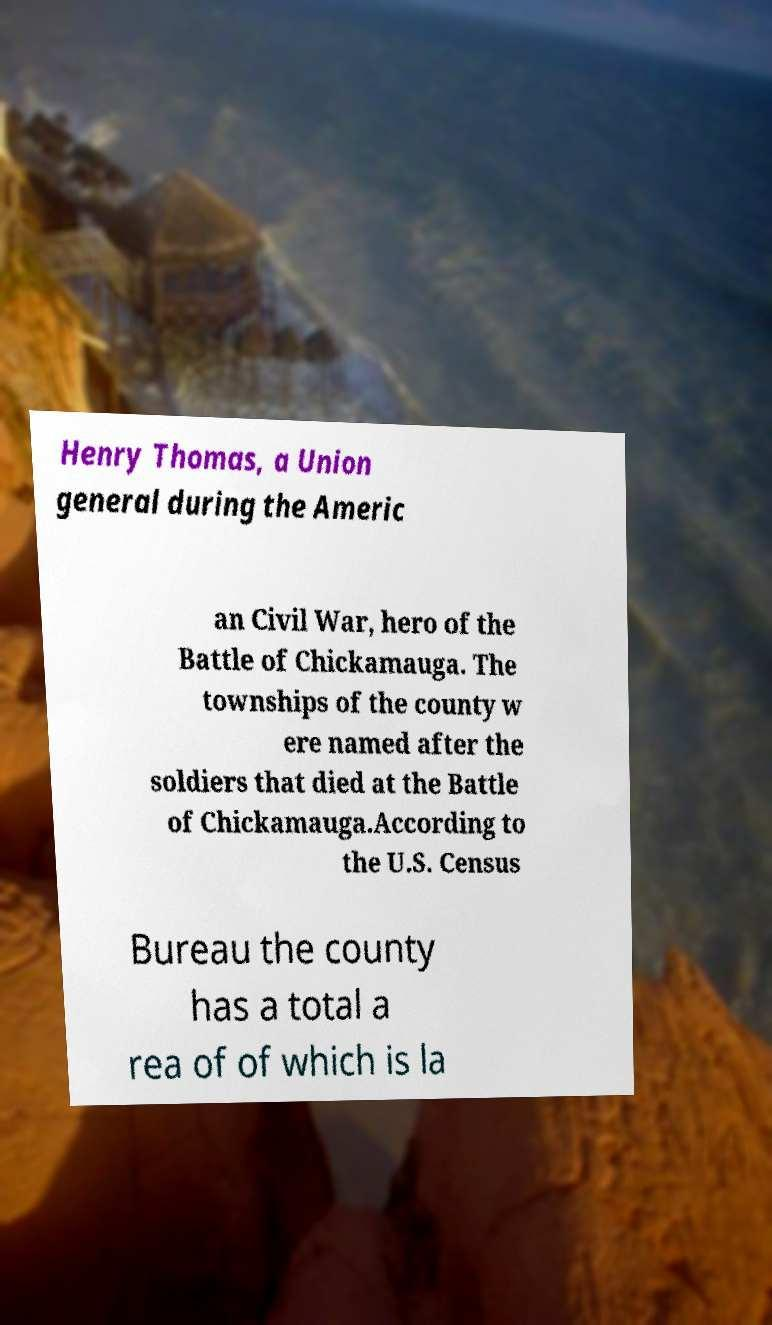Can you read and provide the text displayed in the image?This photo seems to have some interesting text. Can you extract and type it out for me? Henry Thomas, a Union general during the Americ an Civil War, hero of the Battle of Chickamauga. The townships of the county w ere named after the soldiers that died at the Battle of Chickamauga.According to the U.S. Census Bureau the county has a total a rea of of which is la 